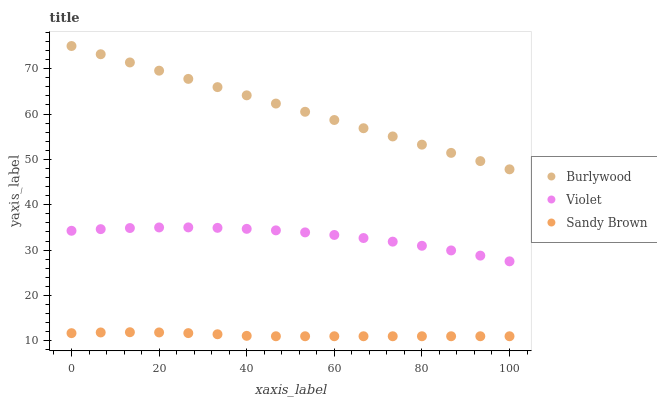Does Sandy Brown have the minimum area under the curve?
Answer yes or no. Yes. Does Burlywood have the maximum area under the curve?
Answer yes or no. Yes. Does Violet have the minimum area under the curve?
Answer yes or no. No. Does Violet have the maximum area under the curve?
Answer yes or no. No. Is Burlywood the smoothest?
Answer yes or no. Yes. Is Violet the roughest?
Answer yes or no. Yes. Is Sandy Brown the smoothest?
Answer yes or no. No. Is Sandy Brown the roughest?
Answer yes or no. No. Does Sandy Brown have the lowest value?
Answer yes or no. Yes. Does Violet have the lowest value?
Answer yes or no. No. Does Burlywood have the highest value?
Answer yes or no. Yes. Does Violet have the highest value?
Answer yes or no. No. Is Sandy Brown less than Burlywood?
Answer yes or no. Yes. Is Burlywood greater than Violet?
Answer yes or no. Yes. Does Sandy Brown intersect Burlywood?
Answer yes or no. No. 